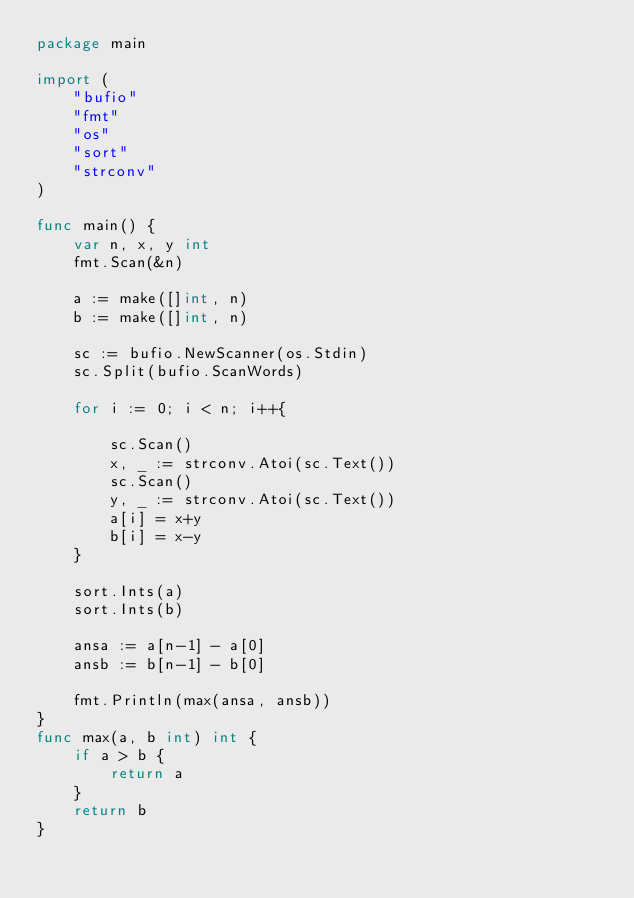<code> <loc_0><loc_0><loc_500><loc_500><_Go_>package main

import (
	"bufio"
	"fmt"
	"os"
	"sort"
	"strconv"
)

func main() {
	var n, x, y int
	fmt.Scan(&n)

	a := make([]int, n)
	b := make([]int, n)

	sc := bufio.NewScanner(os.Stdin)
	sc.Split(bufio.ScanWords)

	for i := 0; i < n; i++{

		sc.Scan()
		x, _ := strconv.Atoi(sc.Text())
		sc.Scan()
		y, _ := strconv.Atoi(sc.Text())
		a[i] = x+y
		b[i] = x-y
	}

	sort.Ints(a)
	sort.Ints(b)

	ansa := a[n-1] - a[0]
	ansb := b[n-1] - b[0]

	fmt.Println(max(ansa, ansb))
}
func max(a, b int) int {
	if a > b {
		return a
	}
	return b
}
</code> 